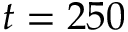Convert formula to latex. <formula><loc_0><loc_0><loc_500><loc_500>t = 2 5 0</formula> 